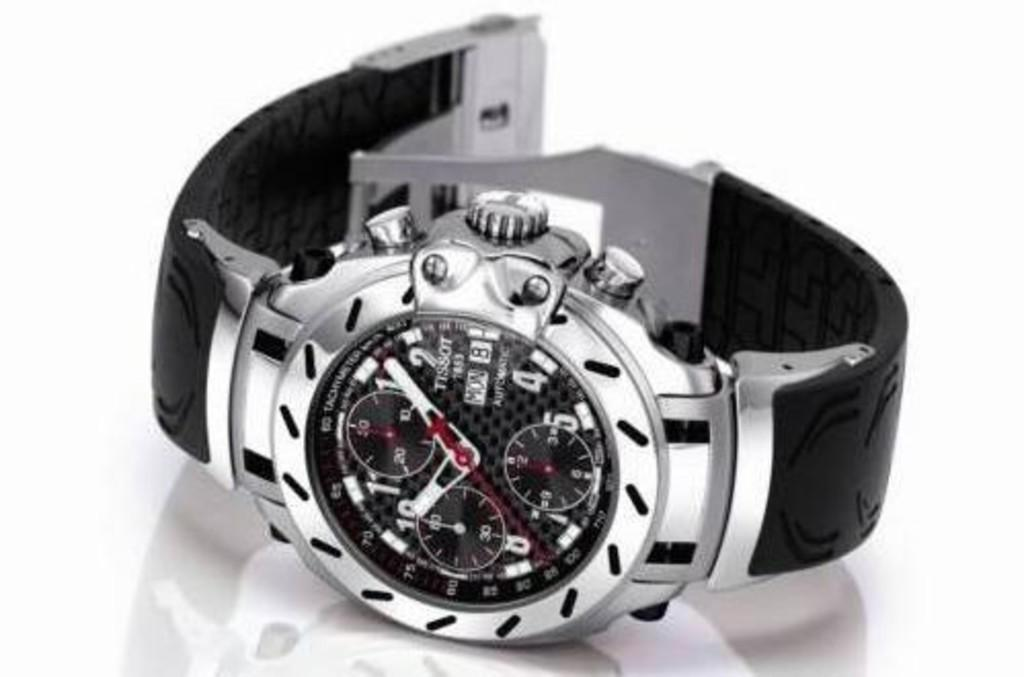<image>
Create a compact narrative representing the image presented. A Tissot brand watch has a black face. 